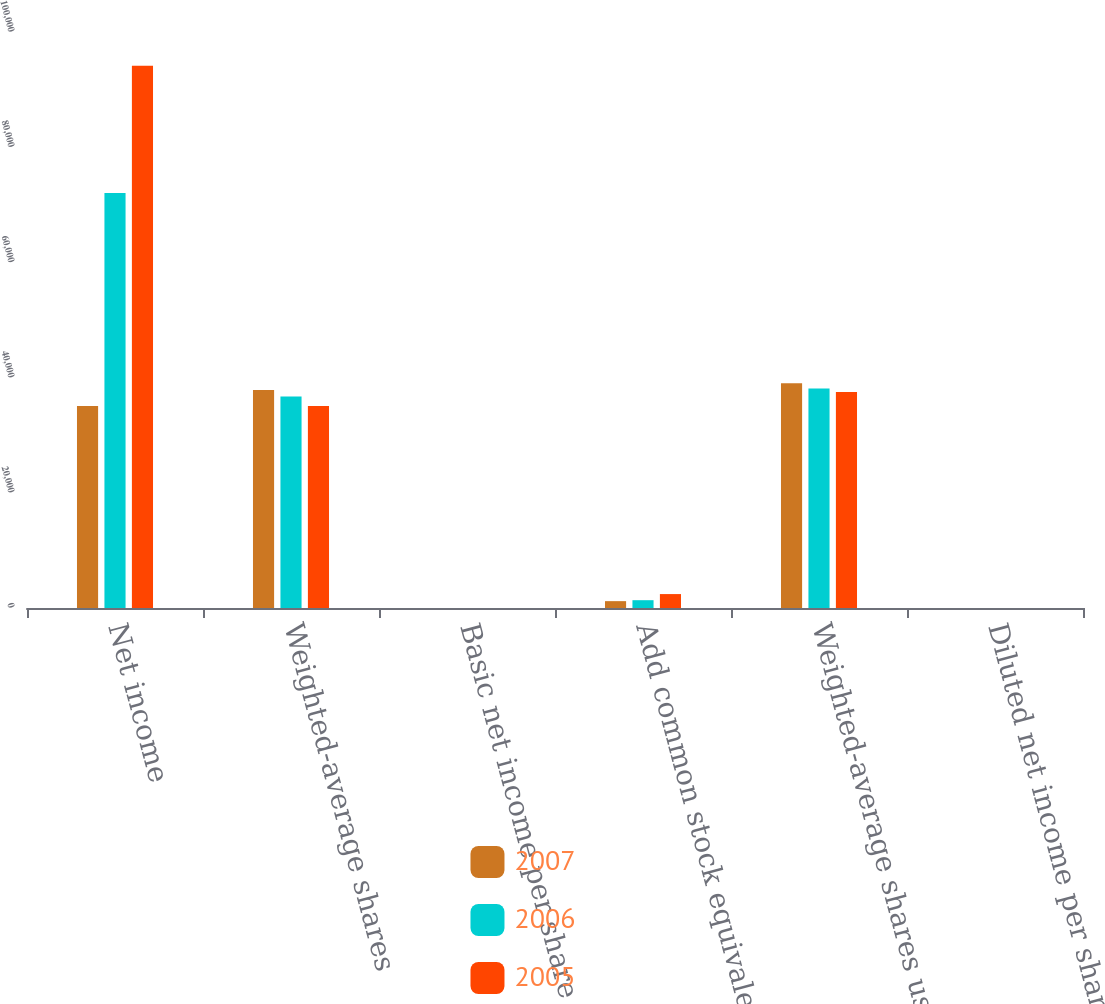<chart> <loc_0><loc_0><loc_500><loc_500><stacked_bar_chart><ecel><fcel>Net income<fcel>Weighted-average shares<fcel>Basic net income per share<fcel>Add common stock equivalents<fcel>Weighted-average shares used<fcel>Diluted net income per share<nl><fcel>2007<fcel>35070<fcel>37831<fcel>3.82<fcel>1190<fcel>39021<fcel>3.7<nl><fcel>2006<fcel>72044<fcel>36737<fcel>1.96<fcel>1356<fcel>38093<fcel>1.89<nl><fcel>2005<fcel>94134<fcel>35070<fcel>2.68<fcel>2418<fcel>37488<fcel>2.51<nl></chart> 